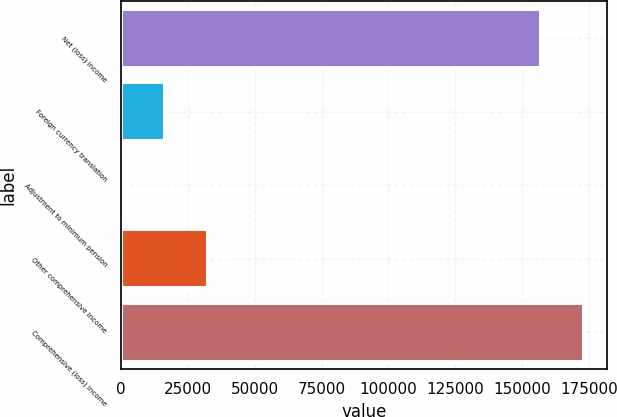Convert chart. <chart><loc_0><loc_0><loc_500><loc_500><bar_chart><fcel>Net (loss) income<fcel>Foreign currency translation<fcel>Adjustment to minimum pension<fcel>Other comprehensive income<fcel>Comprehensive (loss) income<nl><fcel>157150<fcel>16587.8<fcel>764<fcel>32411.6<fcel>172974<nl></chart> 